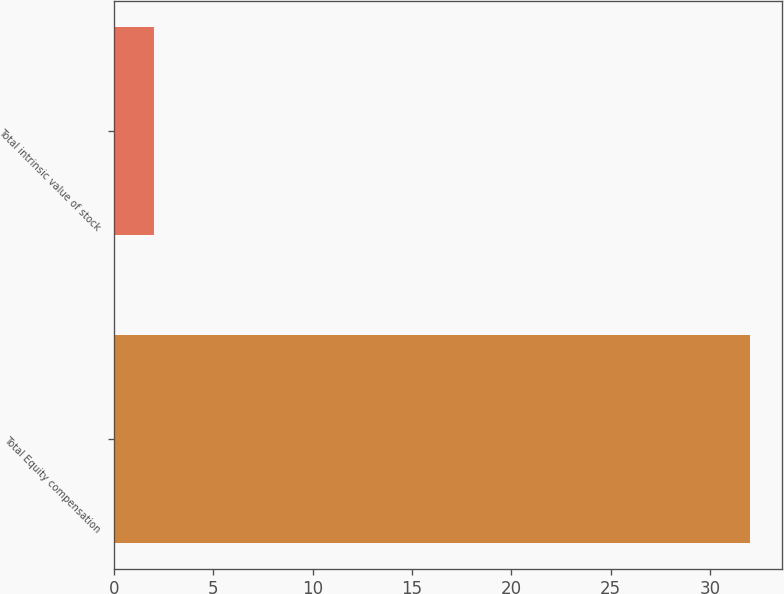Convert chart to OTSL. <chart><loc_0><loc_0><loc_500><loc_500><bar_chart><fcel>Total Equity compensation<fcel>Total intrinsic value of stock<nl><fcel>32<fcel>2<nl></chart> 